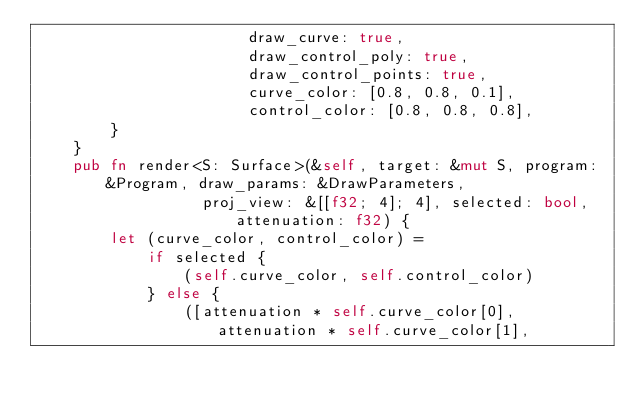<code> <loc_0><loc_0><loc_500><loc_500><_Rust_>                       draw_curve: true,
                       draw_control_poly: true,
                       draw_control_points: true,
                       curve_color: [0.8, 0.8, 0.1],
                       control_color: [0.8, 0.8, 0.8],
        }
    }
    pub fn render<S: Surface>(&self, target: &mut S, program: &Program, draw_params: &DrawParameters,
                  proj_view: &[[f32; 4]; 4], selected: bool, attenuation: f32) {
        let (curve_color, control_color) =
            if selected {
                (self.curve_color, self.control_color)
            } else {
                ([attenuation * self.curve_color[0], attenuation * self.curve_color[1],</code> 